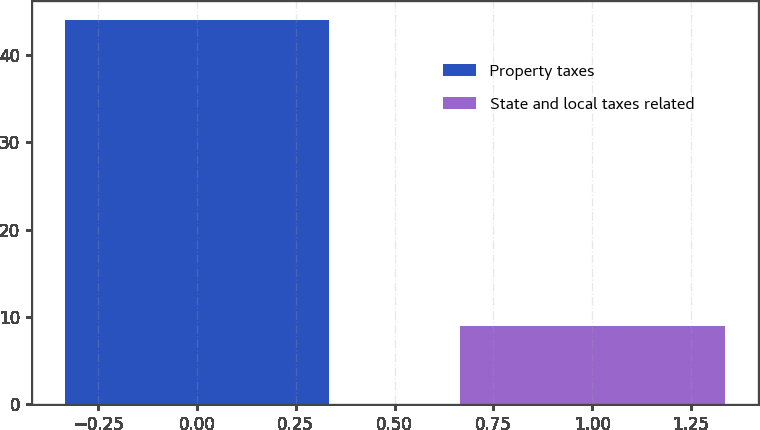<chart> <loc_0><loc_0><loc_500><loc_500><bar_chart><fcel>Property taxes<fcel>State and local taxes related<nl><fcel>44<fcel>9<nl></chart> 